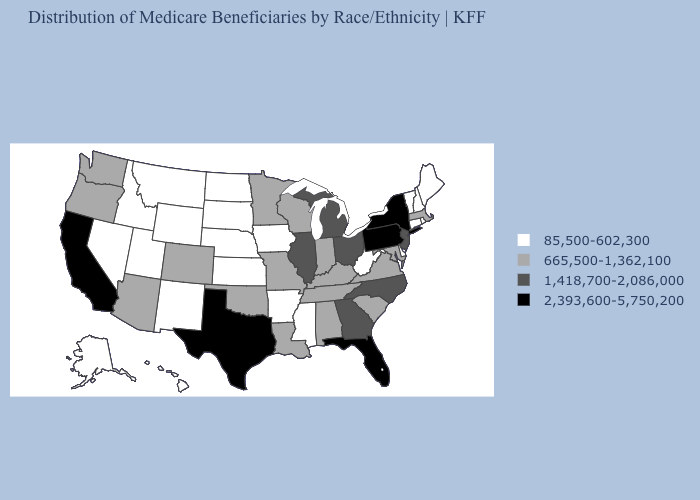Among the states that border New York , which have the lowest value?
Write a very short answer. Connecticut, Vermont. Does Arkansas have the lowest value in the USA?
Be succinct. Yes. Name the states that have a value in the range 2,393,600-5,750,200?
Give a very brief answer. California, Florida, New York, Pennsylvania, Texas. What is the value of Ohio?
Write a very short answer. 1,418,700-2,086,000. Name the states that have a value in the range 85,500-602,300?
Short answer required. Alaska, Arkansas, Connecticut, Delaware, Hawaii, Idaho, Iowa, Kansas, Maine, Mississippi, Montana, Nebraska, Nevada, New Hampshire, New Mexico, North Dakota, Rhode Island, South Dakota, Utah, Vermont, West Virginia, Wyoming. Is the legend a continuous bar?
Give a very brief answer. No. Does Tennessee have the same value as Louisiana?
Quick response, please. Yes. Among the states that border Idaho , which have the highest value?
Short answer required. Oregon, Washington. Which states have the lowest value in the MidWest?
Concise answer only. Iowa, Kansas, Nebraska, North Dakota, South Dakota. Which states have the lowest value in the USA?
Keep it brief. Alaska, Arkansas, Connecticut, Delaware, Hawaii, Idaho, Iowa, Kansas, Maine, Mississippi, Montana, Nebraska, Nevada, New Hampshire, New Mexico, North Dakota, Rhode Island, South Dakota, Utah, Vermont, West Virginia, Wyoming. Which states have the lowest value in the West?
Short answer required. Alaska, Hawaii, Idaho, Montana, Nevada, New Mexico, Utah, Wyoming. Does the map have missing data?
Quick response, please. No. What is the value of Florida?
Be succinct. 2,393,600-5,750,200. Among the states that border Florida , which have the lowest value?
Write a very short answer. Alabama. Name the states that have a value in the range 85,500-602,300?
Short answer required. Alaska, Arkansas, Connecticut, Delaware, Hawaii, Idaho, Iowa, Kansas, Maine, Mississippi, Montana, Nebraska, Nevada, New Hampshire, New Mexico, North Dakota, Rhode Island, South Dakota, Utah, Vermont, West Virginia, Wyoming. 